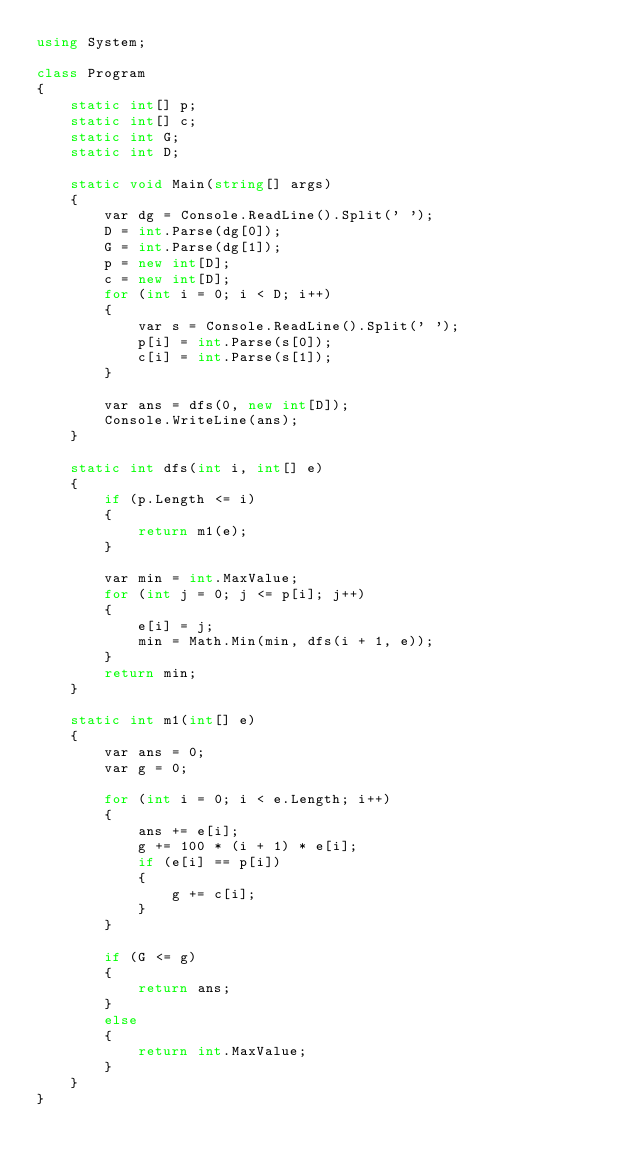Convert code to text. <code><loc_0><loc_0><loc_500><loc_500><_C#_>using System;

class Program
{
    static int[] p;
    static int[] c;
    static int G;
    static int D;

    static void Main(string[] args)
    {
        var dg = Console.ReadLine().Split(' ');
        D = int.Parse(dg[0]);
        G = int.Parse(dg[1]);
        p = new int[D];
        c = new int[D];
        for (int i = 0; i < D; i++)
        {
            var s = Console.ReadLine().Split(' ');
            p[i] = int.Parse(s[0]);
            c[i] = int.Parse(s[1]);
        }

        var ans = dfs(0, new int[D]);
        Console.WriteLine(ans);
    }

    static int dfs(int i, int[] e)
    {
        if (p.Length <= i)
        {
            return m1(e);
        }

        var min = int.MaxValue;
        for (int j = 0; j <= p[i]; j++)
        {
            e[i] = j;
            min = Math.Min(min, dfs(i + 1, e));
        }
        return min;
    }

    static int m1(int[] e)
    {
        var ans = 0;
        var g = 0;

        for (int i = 0; i < e.Length; i++)
        {
            ans += e[i];
            g += 100 * (i + 1) * e[i];
            if (e[i] == p[i])
            {
                g += c[i];
            }
        }

        if (G <= g)
        {
            return ans;
        }
        else
        {
            return int.MaxValue;
        }
    }
}
</code> 